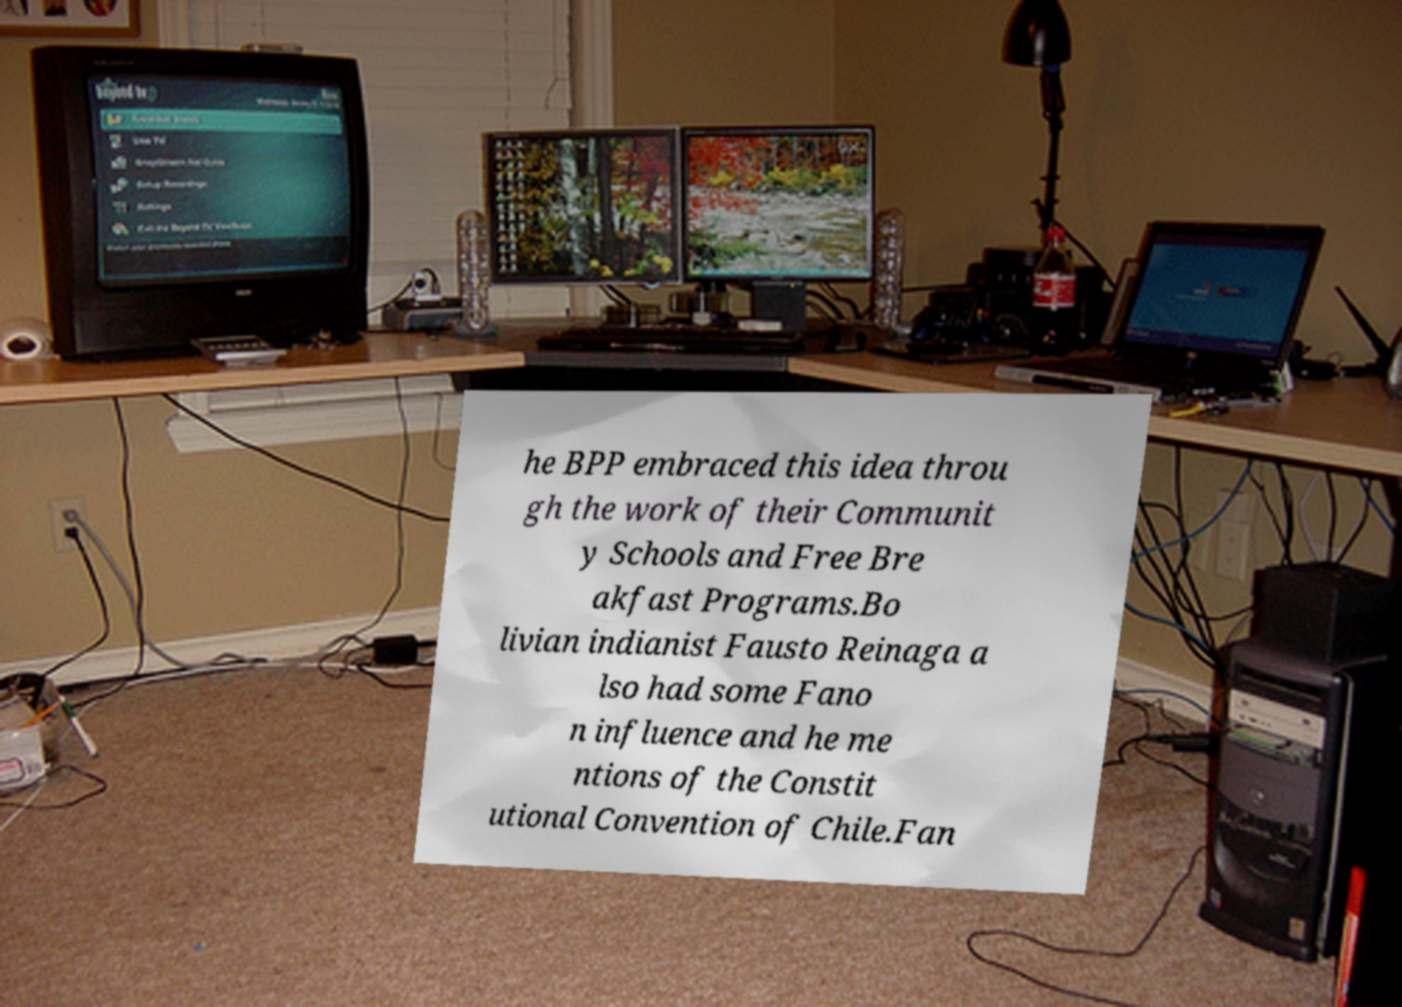What messages or text are displayed in this image? I need them in a readable, typed format. he BPP embraced this idea throu gh the work of their Communit y Schools and Free Bre akfast Programs.Bo livian indianist Fausto Reinaga a lso had some Fano n influence and he me ntions of the Constit utional Convention of Chile.Fan 